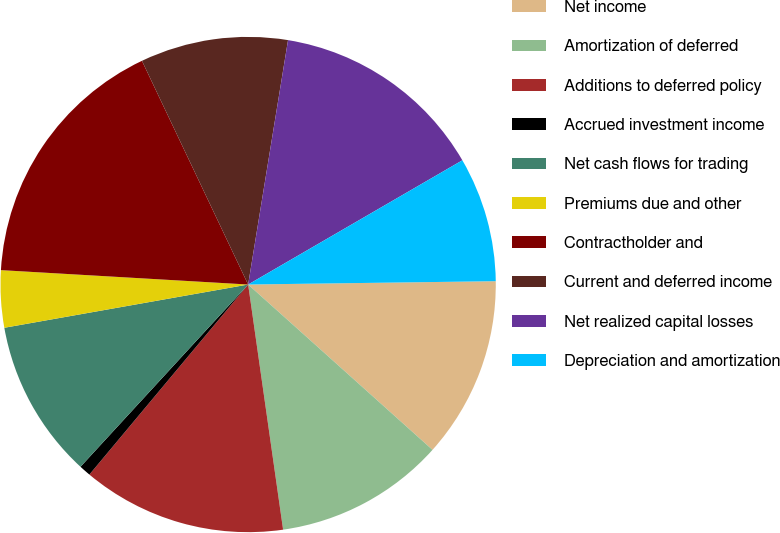Convert chart. <chart><loc_0><loc_0><loc_500><loc_500><pie_chart><fcel>Net income<fcel>Amortization of deferred<fcel>Additions to deferred policy<fcel>Accrued investment income<fcel>Net cash flows for trading<fcel>Premiums due and other<fcel>Contractholder and<fcel>Current and deferred income<fcel>Net realized capital losses<fcel>Depreciation and amortization<nl><fcel>11.85%<fcel>11.11%<fcel>13.33%<fcel>0.76%<fcel>10.37%<fcel>3.72%<fcel>17.02%<fcel>9.63%<fcel>14.06%<fcel>8.15%<nl></chart> 